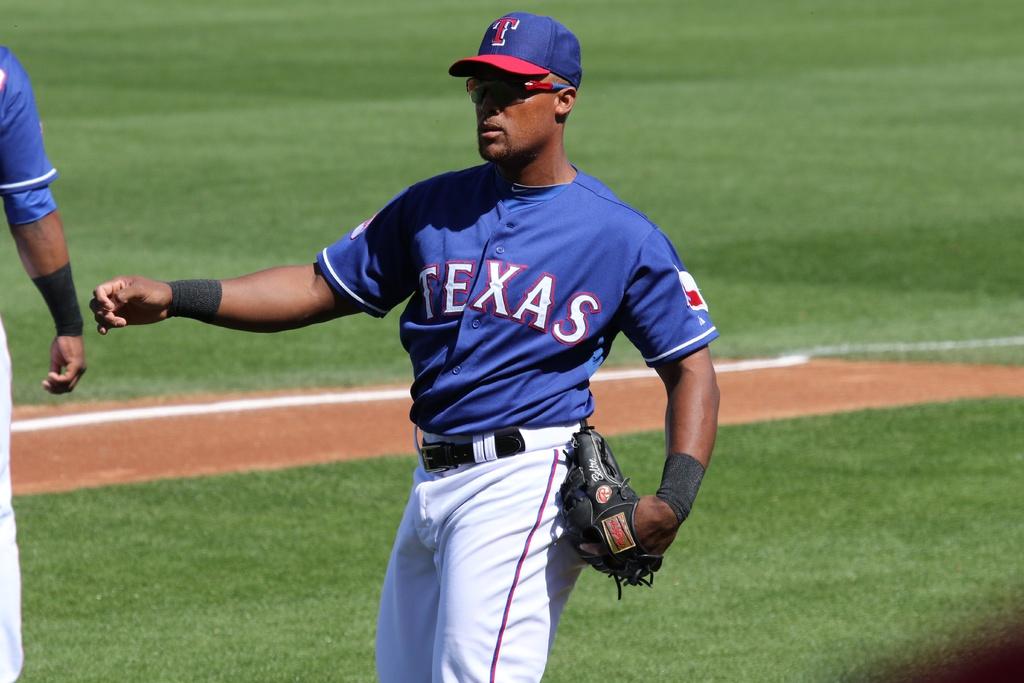What team is he on?
Give a very brief answer. Texas. 